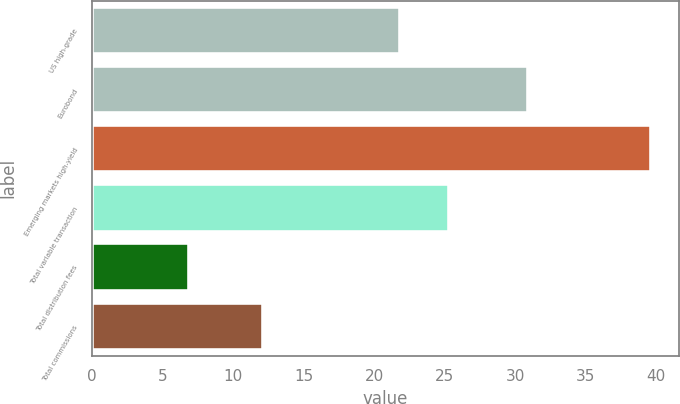Convert chart to OTSL. <chart><loc_0><loc_0><loc_500><loc_500><bar_chart><fcel>US high-grade<fcel>Eurobond<fcel>Emerging markets high-yield<fcel>Total variable transaction<fcel>Total distribution fees<fcel>Total commissions<nl><fcel>21.8<fcel>30.9<fcel>39.6<fcel>25.3<fcel>6.9<fcel>12.1<nl></chart> 